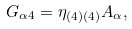<formula> <loc_0><loc_0><loc_500><loc_500>G _ { \alpha 4 } = \eta _ { ( 4 ) ( 4 ) } A _ { \alpha } ,</formula> 